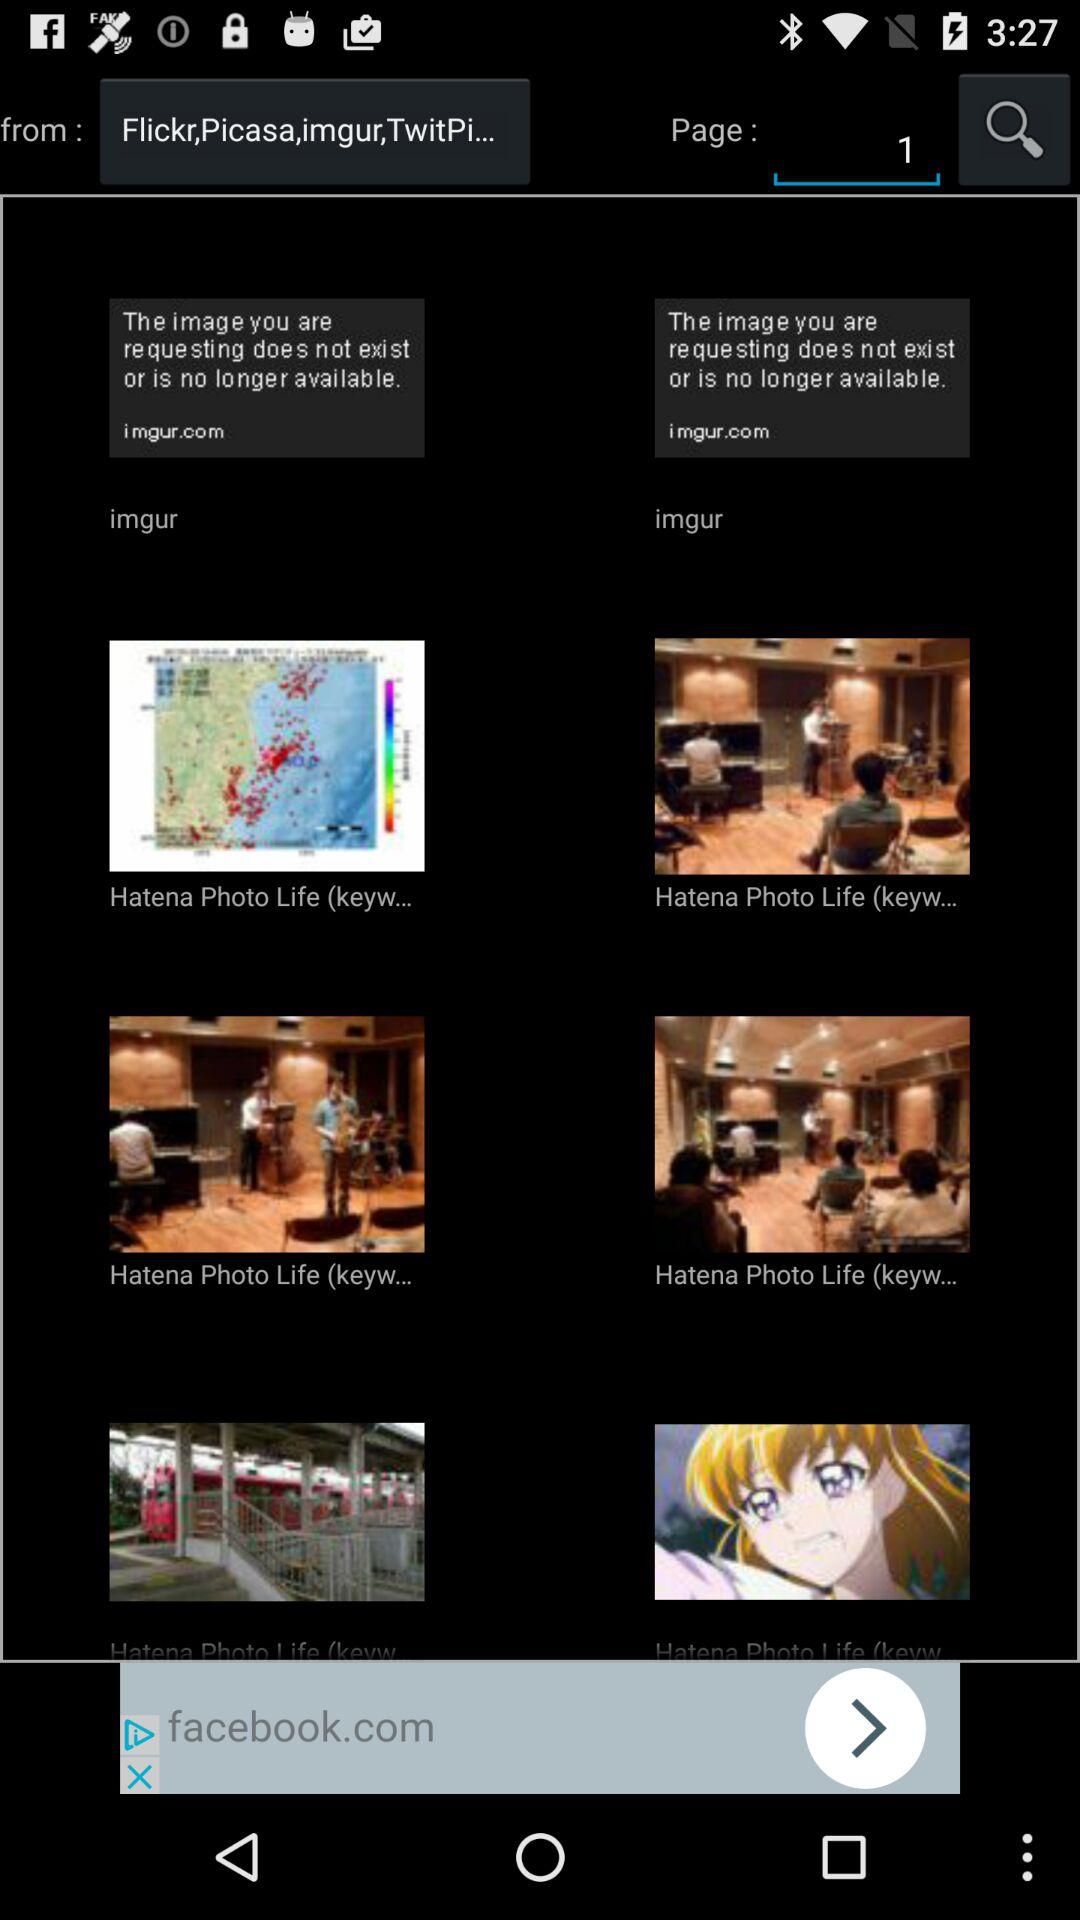How many pages are there? There is 1 page. 